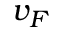<formula> <loc_0><loc_0><loc_500><loc_500>v _ { F }</formula> 